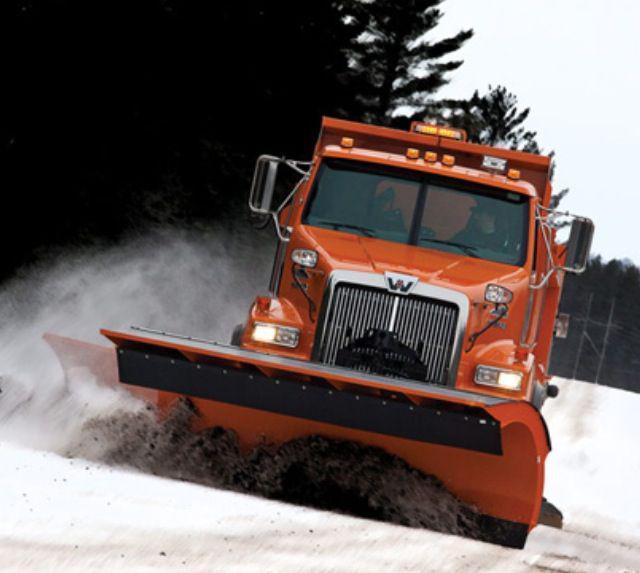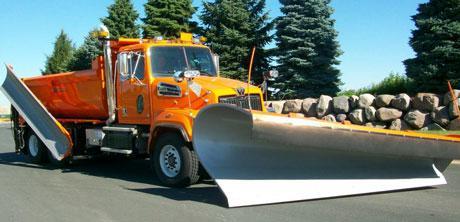The first image is the image on the left, the second image is the image on the right. Evaluate the accuracy of this statement regarding the images: "There is a snowplow plowing snow.". Is it true? Answer yes or no. Yes. 